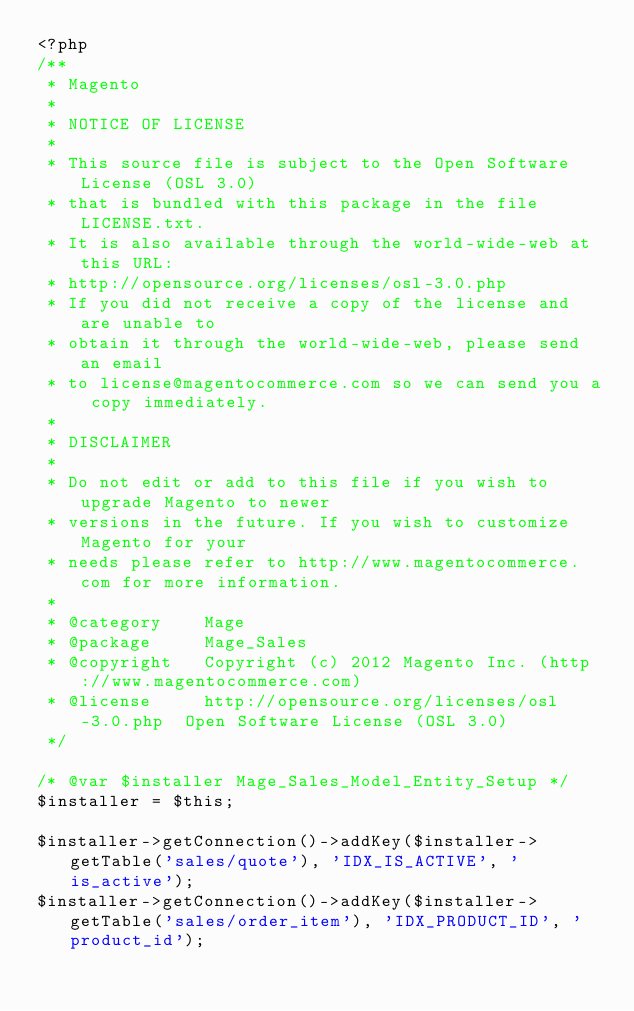<code> <loc_0><loc_0><loc_500><loc_500><_PHP_><?php
/**
 * Magento
 *
 * NOTICE OF LICENSE
 *
 * This source file is subject to the Open Software License (OSL 3.0)
 * that is bundled with this package in the file LICENSE.txt.
 * It is also available through the world-wide-web at this URL:
 * http://opensource.org/licenses/osl-3.0.php
 * If you did not receive a copy of the license and are unable to
 * obtain it through the world-wide-web, please send an email
 * to license@magentocommerce.com so we can send you a copy immediately.
 *
 * DISCLAIMER
 *
 * Do not edit or add to this file if you wish to upgrade Magento to newer
 * versions in the future. If you wish to customize Magento for your
 * needs please refer to http://www.magentocommerce.com for more information.
 *
 * @category    Mage
 * @package     Mage_Sales
 * @copyright   Copyright (c) 2012 Magento Inc. (http://www.magentocommerce.com)
 * @license     http://opensource.org/licenses/osl-3.0.php  Open Software License (OSL 3.0)
 */

/* @var $installer Mage_Sales_Model_Entity_Setup */
$installer = $this;

$installer->getConnection()->addKey($installer->getTable('sales/quote'), 'IDX_IS_ACTIVE', 'is_active');
$installer->getConnection()->addKey($installer->getTable('sales/order_item'), 'IDX_PRODUCT_ID', 'product_id');
</code> 